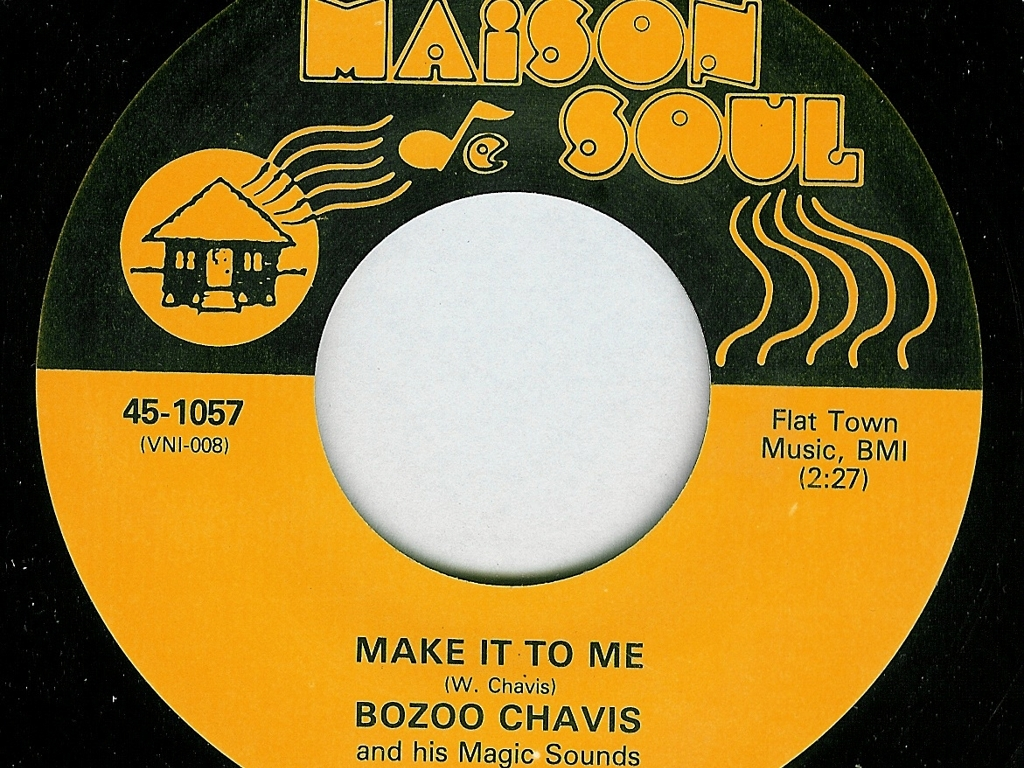This record label mentions BMI. Can you explain what that is? BMI stands for Broadcast Music, Inc., which is one of the United States' performing rights organizations (PROs). PROs collect license fees on behalf of songwriters, composers, and music publishers and distribute them as royalties to those members whose works have been performed. In this context, the mention of BMI indicates that the music on this record is registered with BMI, and that they manage the performance rights for the piece titled 'MAKE IT TO ME.' 